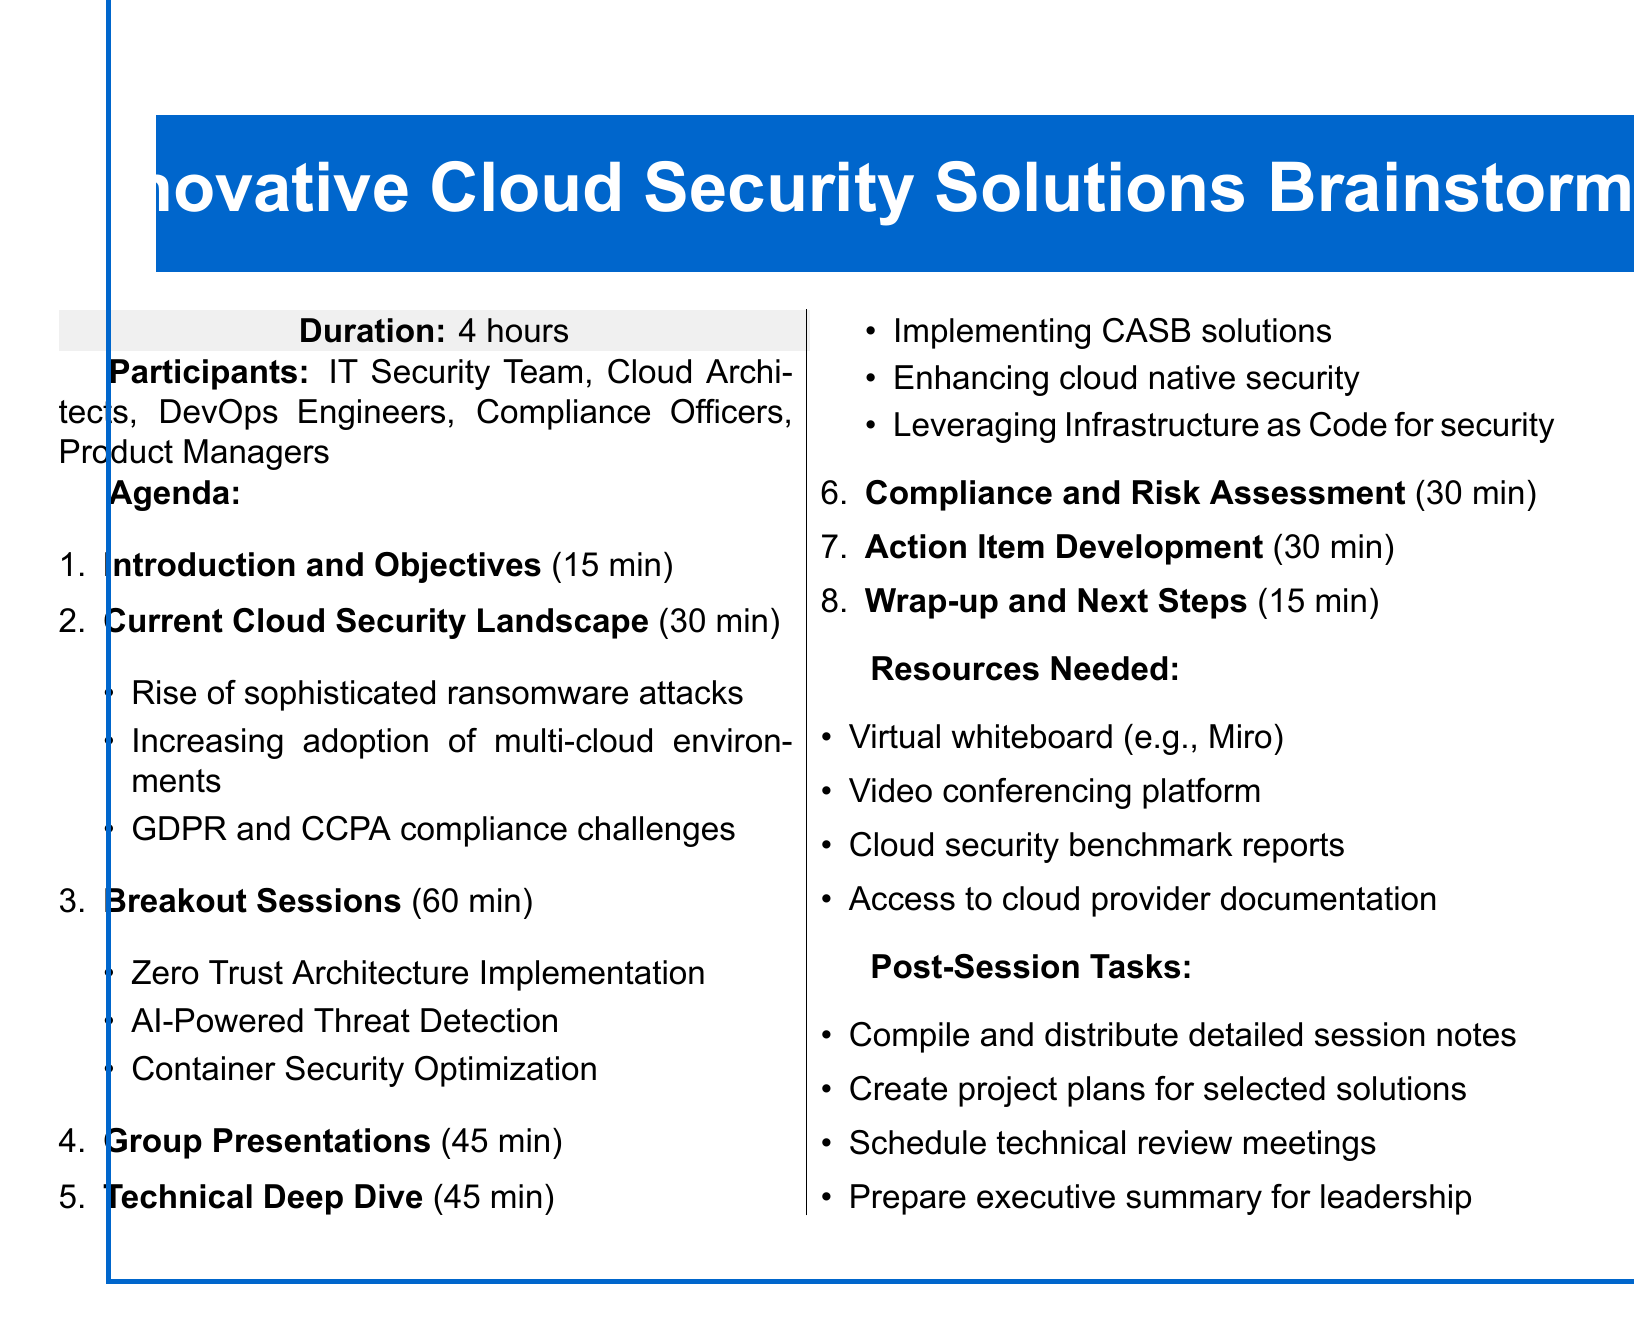What is the title of the session? The title of the session is provided in the session overview.
Answer: Innovative Cloud Security Solutions Brainstorming How long is the duration of the session? The duration of the session is specified in the session overview.
Answer: 4 hours Who are the participants? The participants listed include various roles that will contribute to the session.
Answer: IT Security Team, Cloud Architects, DevOps Engineers, Compliance Officers, Product Managers What is one focus area of the breakout sessions? The breakout sessions have specific focus areas mentioned in the agenda.
Answer: Zero Trust Architecture Implementation How long is allocated for group presentations? The agenda specifies the duration allocated for group presentations.
Answer: 45 minutes What type of tasks are required after the session? The document lists tasks that need to be performed after the session.
Answer: Compile and distribute detailed session notes What is a key compliance focus area discussed during the session? The agenda highlights specific focus areas related to compliance.
Answer: Mapping innovative solutions to compliance requirements How many minutes are dedicated to the "Current Cloud Security Landscape"? The duration for this agenda item is explicitly stated.
Answer: 30 minutes What resource is needed to facilitate virtual collaboration? The resources required for the session include tools for virtual collaboration.
Answer: Virtual whiteboard (e.g., Miro) 